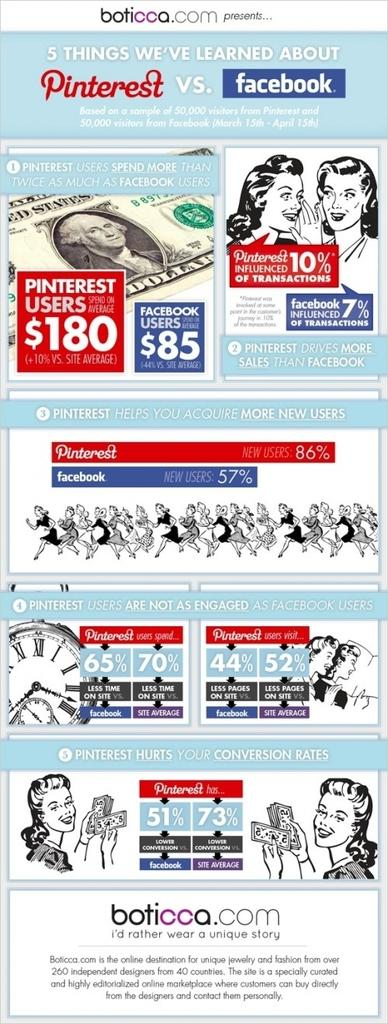What is the main subject of the image? The main subject of the image is a group of persons. Are there any other elements in the image besides the group of persons? Yes, there is text, a clock, and a currency note in the image. What type of beef can be seen in the image? There is no beef present in the image. How many animals can be seen at the zoo in the image? There is no zoo present in the image. 